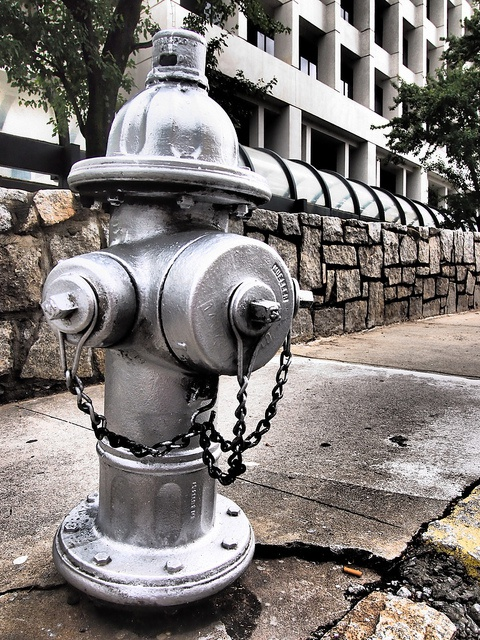Describe the objects in this image and their specific colors. I can see a fire hydrant in black, lightgray, gray, and darkgray tones in this image. 